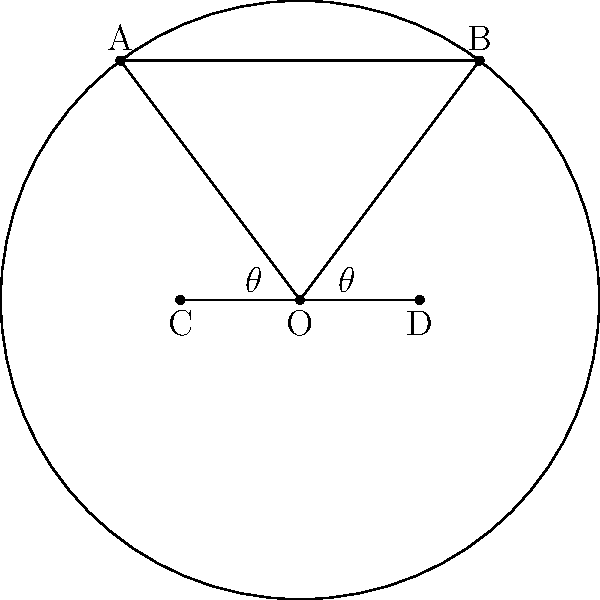In a rugby field, the goalposts are represented by points A and B, while the touchline is represented by points C and D. If the center of the field is at point O, and the angle $\theta$ is formed between OC and OA (and similarly between OD and OB), what is the value of $\theta$ given that the distance between the goalposts (AB) is 5.6 meters and the distance from the center to the touchline (OC or OD) is 10 meters? Let's approach this step-by-step:

1) First, we need to recognize that OACB forms a right triangle, with OC being perpendicular to AB.

2) We're given that AB = 5.6 meters and OC = 10 meters.

3) In the right triangle OAC:
   $\tan(\theta) = \frac{AC}{OC}$

4) AC is half of AB, so $AC = 5.6/2 = 2.8$ meters

5) Now we can calculate $\theta$:
   $\theta = \arctan(\frac{2.8}{10})$

6) Using a calculator or trigonometric tables:
   $\theta \approx 15.64^\circ$

7) We can verify this by checking that:
   $\cos(\theta) = \frac{OC}{OA} = \frac{10}{\sqrt{10^2 + 2.8^2}} \approx 0.9628$
   
   Which indeed corresponds to an angle of about 15.64°.
Answer: $\theta \approx 15.64^\circ$ 